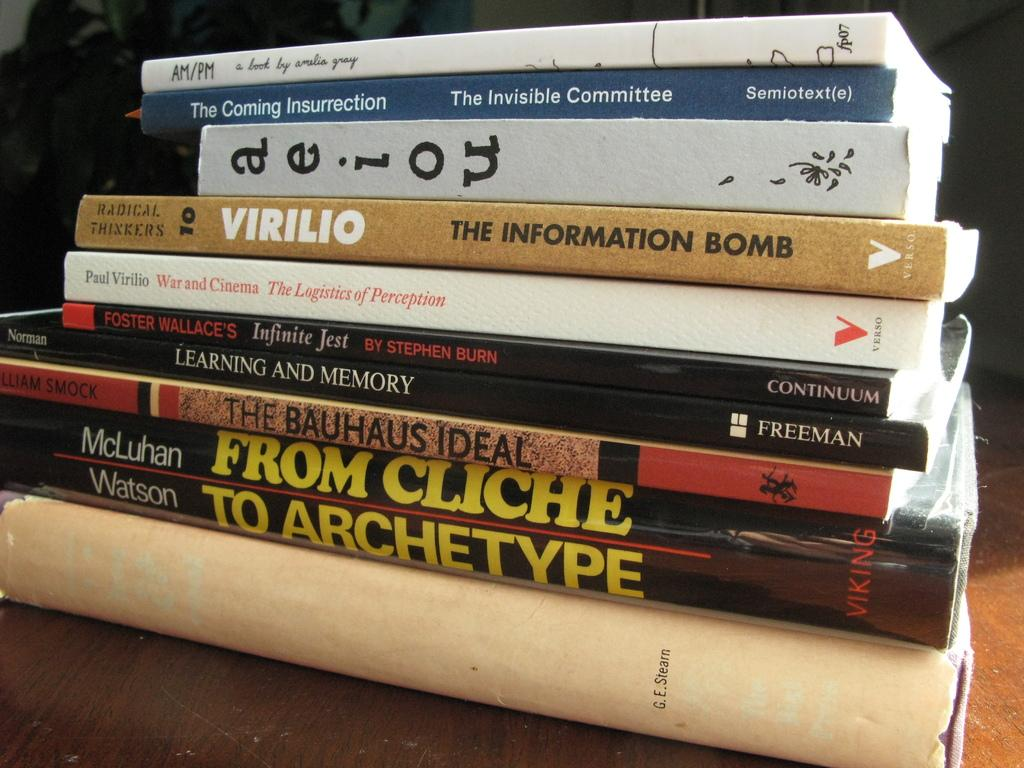<image>
Give a short and clear explanation of the subsequent image. a variety of books stacked on top of each other including "from cliche to archetype". 